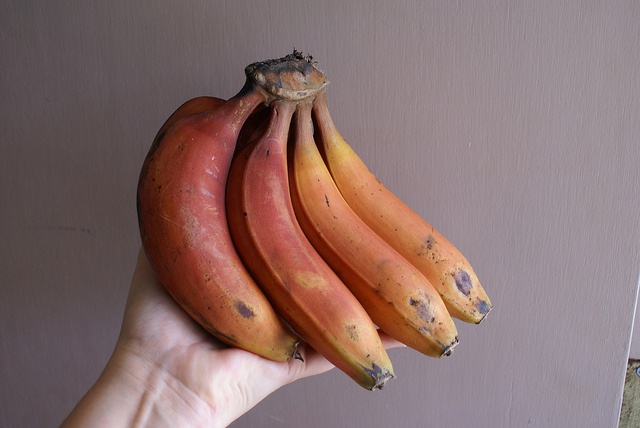Describe the objects in this image and their specific colors. I can see banana in gray, maroon, brown, and black tones, people in gray, darkgray, and lightgray tones, banana in gray, maroon, brown, and salmon tones, banana in gray, brown, tan, maroon, and salmon tones, and banana in gray, tan, and red tones in this image. 